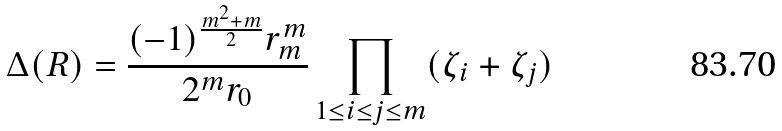Convert formula to latex. <formula><loc_0><loc_0><loc_500><loc_500>\Delta ( R ) = \frac { ( - 1 ) ^ { \frac { m ^ { 2 } + m } { 2 } } r _ { m } ^ { m } } { 2 ^ { m } r _ { 0 } } \prod _ { 1 \leq i \leq j \leq m } ( \zeta _ { i } + \zeta _ { j } )</formula> 